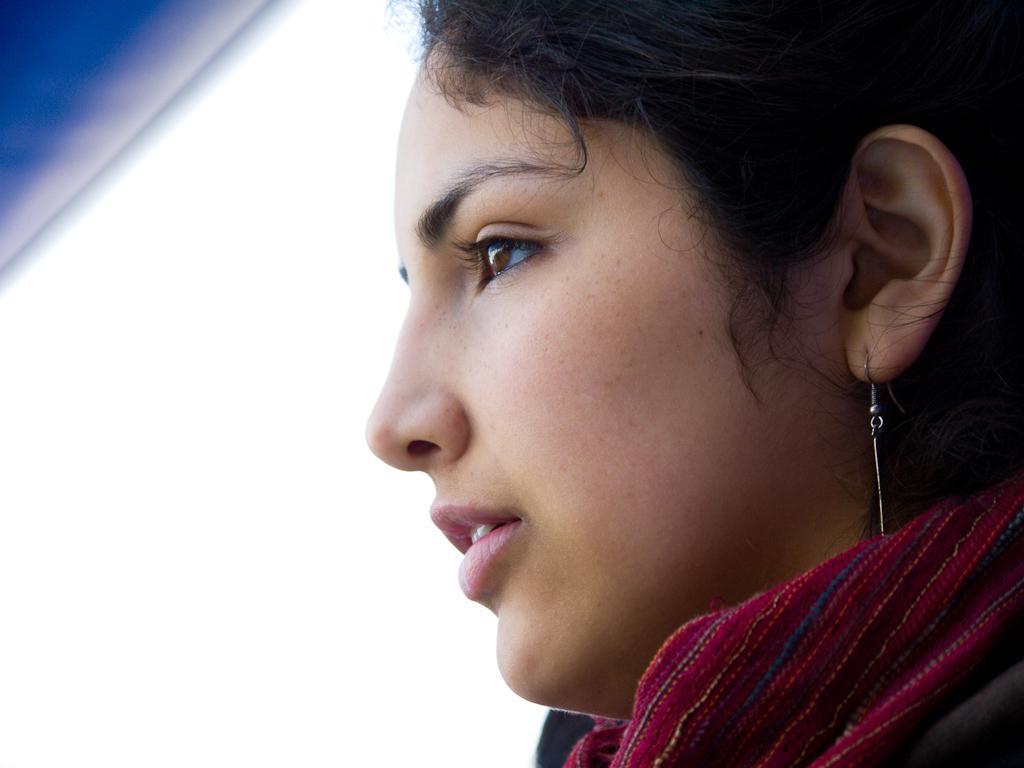In one or two sentences, can you explain what this image depicts? In this image there is a woman wearing scarf and earrings. Left top there is an object. 